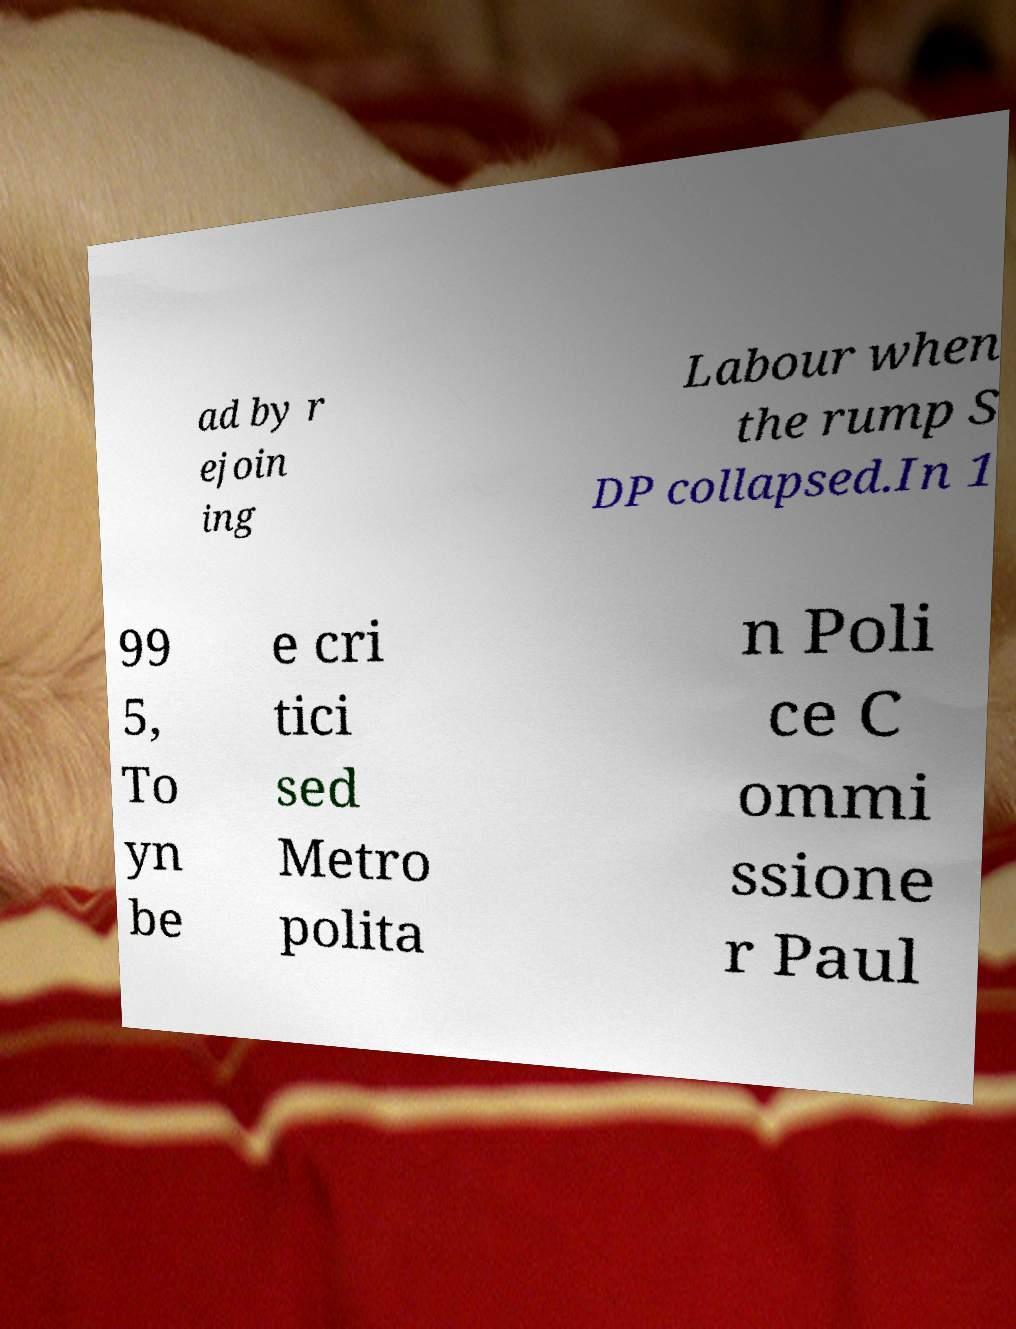Can you read and provide the text displayed in the image?This photo seems to have some interesting text. Can you extract and type it out for me? ad by r ejoin ing Labour when the rump S DP collapsed.In 1 99 5, To yn be e cri tici sed Metro polita n Poli ce C ommi ssione r Paul 